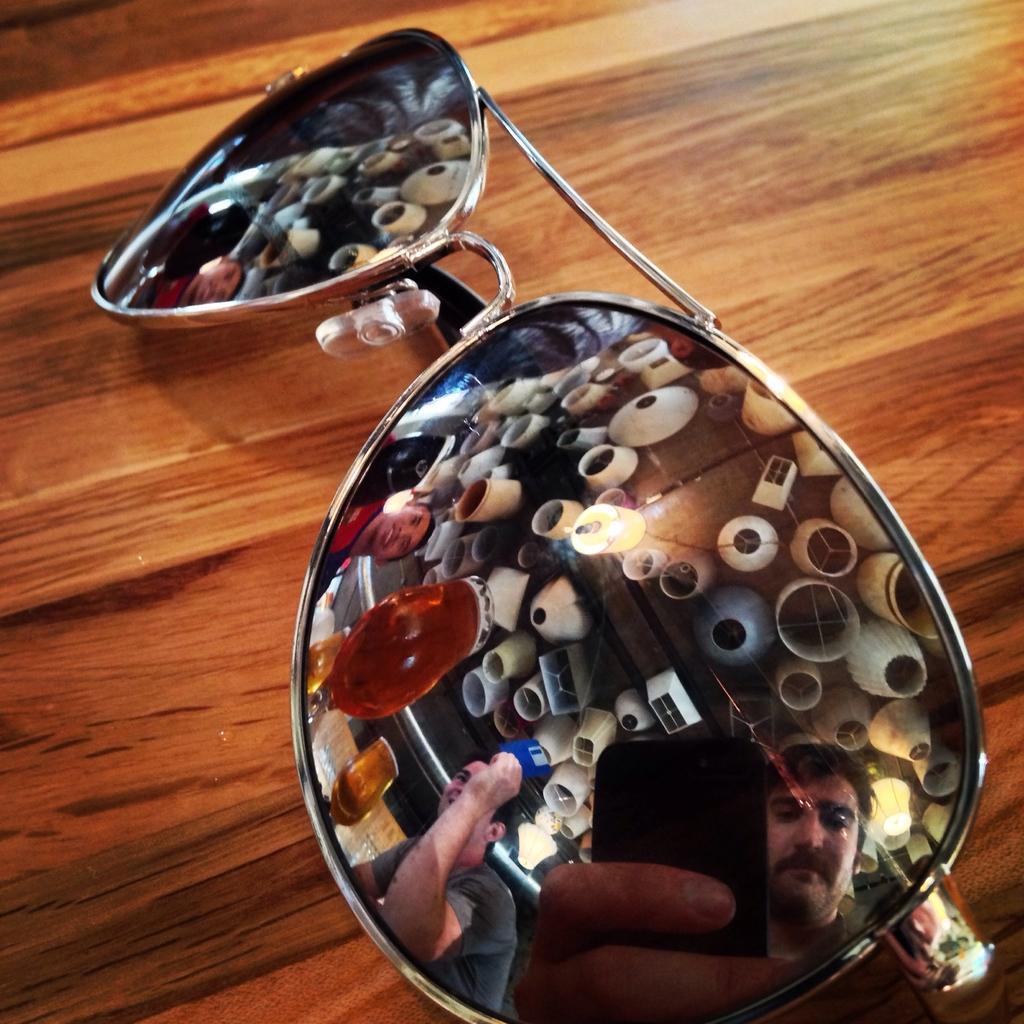Describe this image in one or two sentences. In this picture sunglasses are placed on the table and on the sunglasses there is a reflection of people who are present inside the room. 